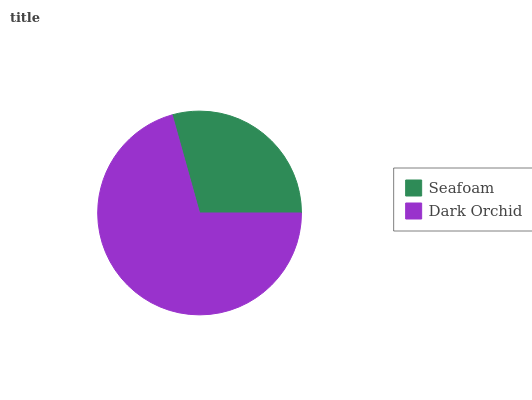Is Seafoam the minimum?
Answer yes or no. Yes. Is Dark Orchid the maximum?
Answer yes or no. Yes. Is Dark Orchid the minimum?
Answer yes or no. No. Is Dark Orchid greater than Seafoam?
Answer yes or no. Yes. Is Seafoam less than Dark Orchid?
Answer yes or no. Yes. Is Seafoam greater than Dark Orchid?
Answer yes or no. No. Is Dark Orchid less than Seafoam?
Answer yes or no. No. Is Dark Orchid the high median?
Answer yes or no. Yes. Is Seafoam the low median?
Answer yes or no. Yes. Is Seafoam the high median?
Answer yes or no. No. Is Dark Orchid the low median?
Answer yes or no. No. 